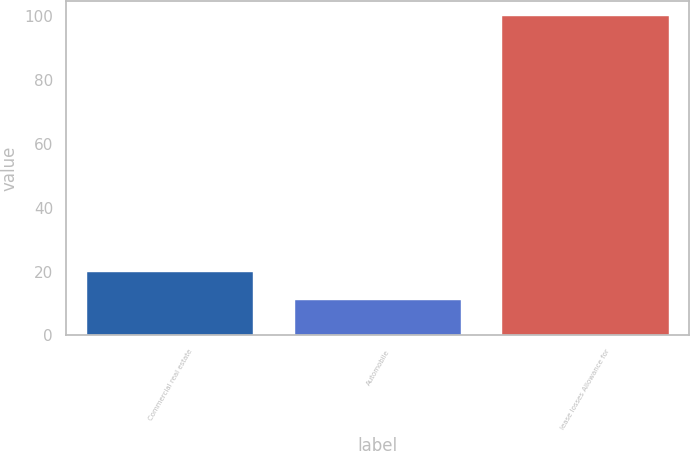Convert chart to OTSL. <chart><loc_0><loc_0><loc_500><loc_500><bar_chart><fcel>Commercial real estate<fcel>Automobile<fcel>lease losses Allowance for<nl><fcel>19.9<fcel>11<fcel>100<nl></chart> 